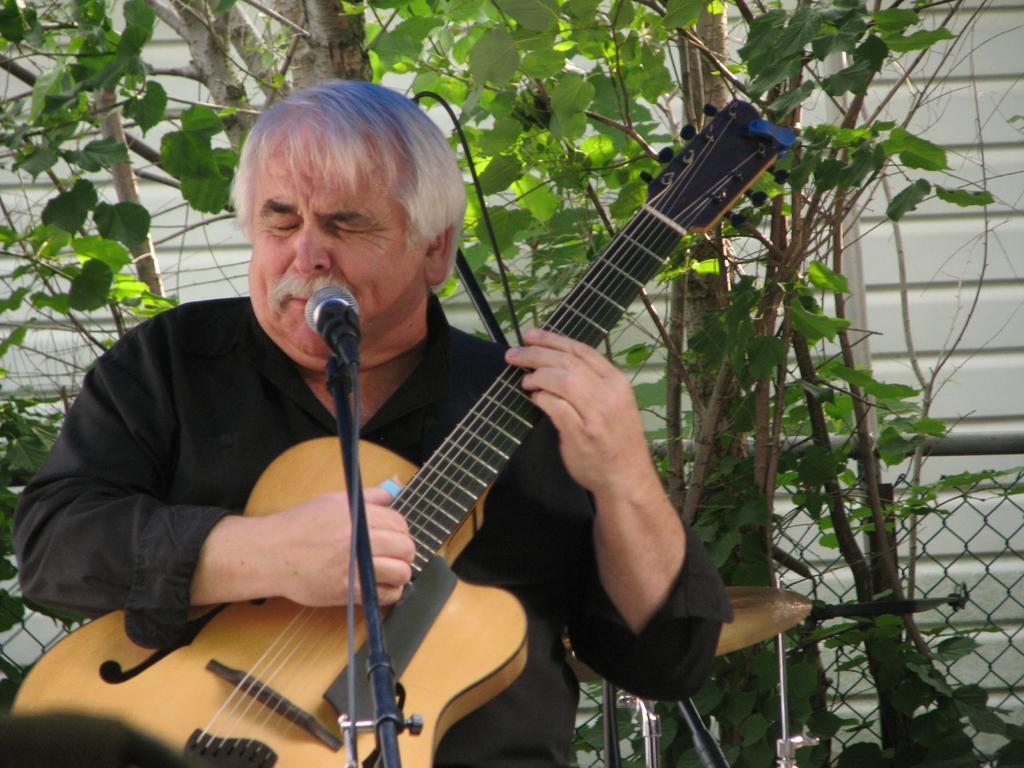What is the person in the image doing? The person is sitting and playing a guitar. What object is in front of the person? There is a microphone with a stand in front of the person. What can be seen in the background of the image? There is a wall, a fence, a rod, a drum plate, and a tree in the background. What type of quiet achiever can be seen in the image? There is no reference to a quiet achiever in the image; it features a person playing a guitar and various background elements. 